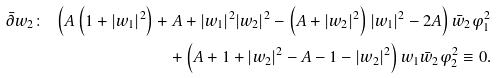<formula> <loc_0><loc_0><loc_500><loc_500>\bar { \partial } w _ { 2 } \colon \ \left ( A \left ( 1 + | w _ { 1 } | ^ { 2 } \right ) + A + | w _ { 1 } | ^ { 2 } | w _ { 2 } | ^ { 2 } - \left ( A + | w _ { 2 } | ^ { 2 } \right ) | w _ { 1 } | ^ { 2 } - 2 A \right ) \bar { w } _ { 2 } \varphi _ { 1 } ^ { 2 } \\ + \left ( A + 1 + | w _ { 2 } | ^ { 2 } - A - 1 - | w _ { 2 } | ^ { 2 } \right ) w _ { 1 } \bar { w } _ { 2 } \varphi _ { 2 } ^ { 2 } \equiv 0 .</formula> 